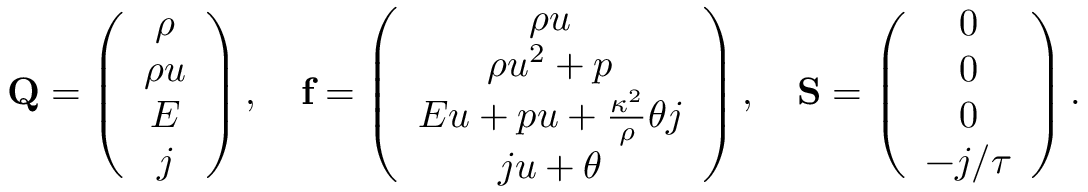Convert formula to latex. <formula><loc_0><loc_0><loc_500><loc_500>Q = \left ( \begin{array} { c } { \rho } \\ { \rho u } \\ { E } \\ { j } \end{array} \right ) , \quad f = \left ( \begin{array} { c } { \rho u } \\ { \rho u ^ { 2 } + p } \\ { E u + p u + \frac { \kappa ^ { 2 } } { \rho } \theta j } \\ { j u + \theta } \end{array} \right ) , \quad S = \left ( \begin{array} { c } { 0 } \\ { 0 } \\ { 0 } \\ { - j / \tau } \end{array} \right ) .</formula> 